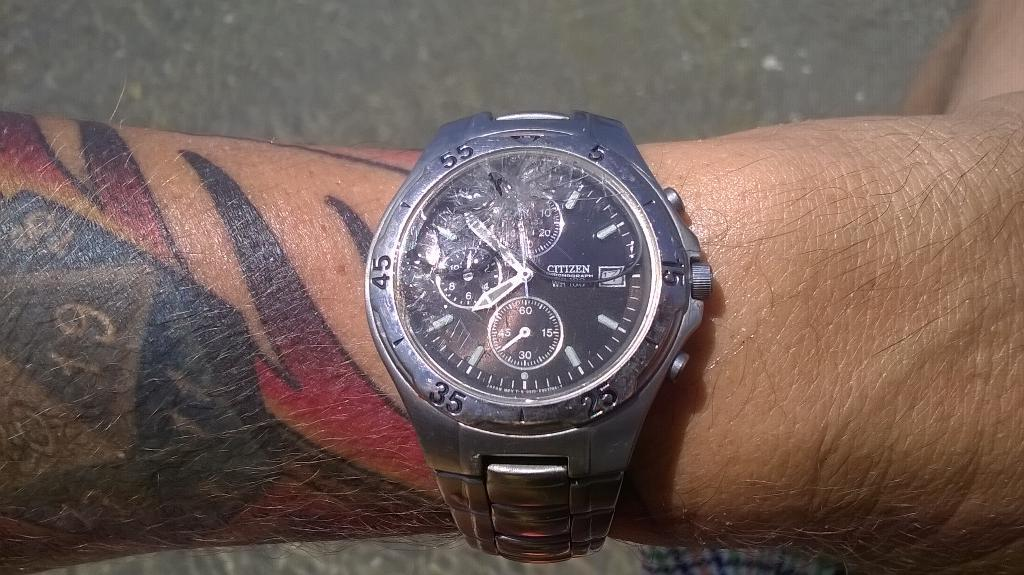What can be seen on the person's hand in the image? There is a tattoo and numbers visible on the person's hand. What else is on the person's hand in the image? There is a watch on the person's hand. What can be seen in the background of the image? There is a road visible in the image. What type of stew is being prepared on the person's hand in the image? There is no stew being prepared on the person's hand in the image; it only shows a tattoo, numbers, and a watch. 